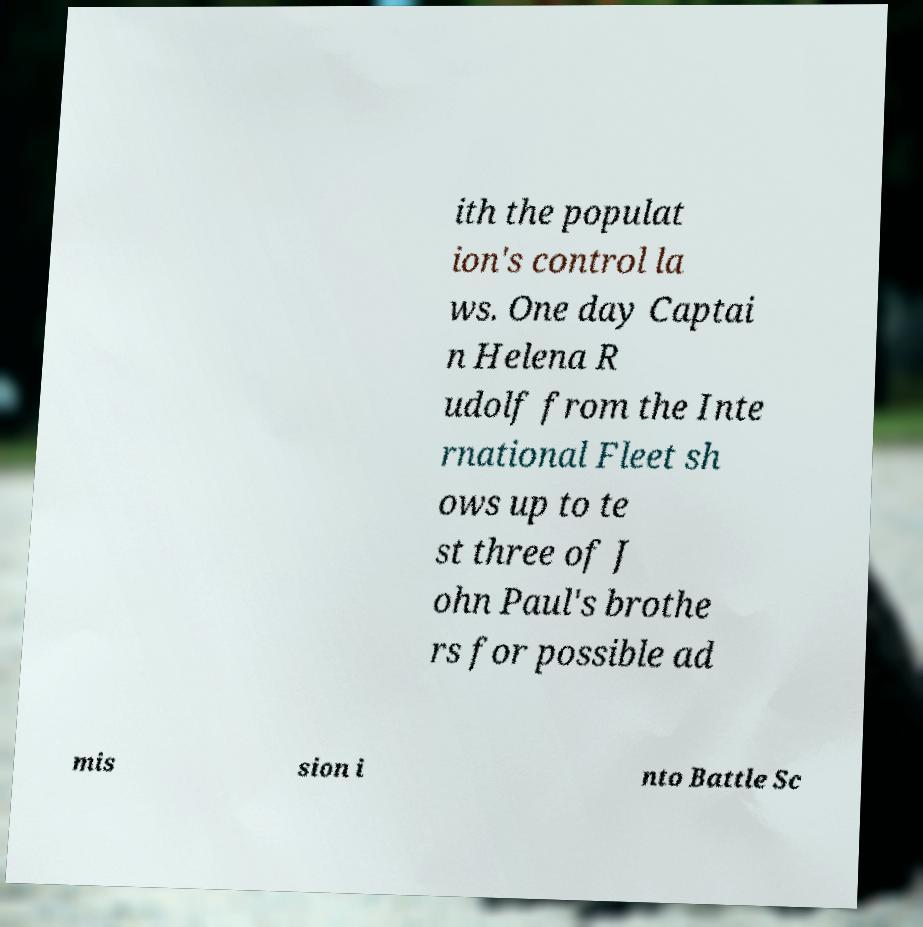Could you extract and type out the text from this image? ith the populat ion's control la ws. One day Captai n Helena R udolf from the Inte rnational Fleet sh ows up to te st three of J ohn Paul's brothe rs for possible ad mis sion i nto Battle Sc 